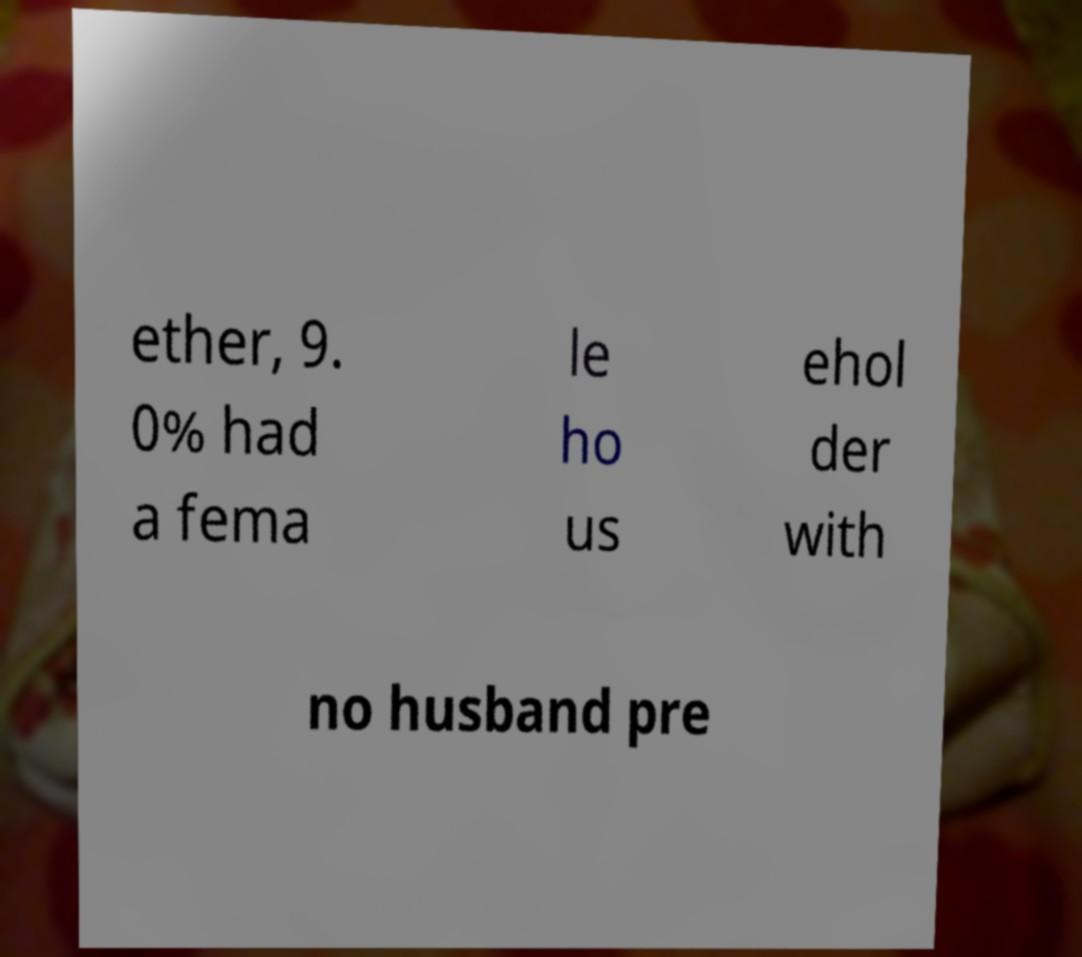For documentation purposes, I need the text within this image transcribed. Could you provide that? ether, 9. 0% had a fema le ho us ehol der with no husband pre 